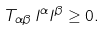<formula> <loc_0><loc_0><loc_500><loc_500>T _ { \alpha \beta } \, l ^ { \alpha } l ^ { \beta } \geq 0 .</formula> 